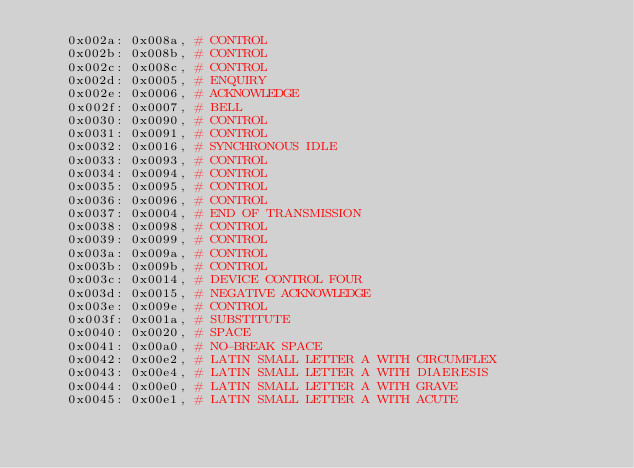Convert code to text. <code><loc_0><loc_0><loc_500><loc_500><_Python_>	0x002a: 0x008a,	# CONTROL
	0x002b: 0x008b,	# CONTROL
	0x002c: 0x008c,	# CONTROL
	0x002d: 0x0005,	# ENQUIRY
	0x002e: 0x0006,	# ACKNOWLEDGE
	0x002f: 0x0007,	# BELL
	0x0030: 0x0090,	# CONTROL
	0x0031: 0x0091,	# CONTROL
	0x0032: 0x0016,	# SYNCHRONOUS IDLE
	0x0033: 0x0093,	# CONTROL
	0x0034: 0x0094,	# CONTROL
	0x0035: 0x0095,	# CONTROL
	0x0036: 0x0096,	# CONTROL
	0x0037: 0x0004,	# END OF TRANSMISSION
	0x0038: 0x0098,	# CONTROL
	0x0039: 0x0099,	# CONTROL
	0x003a: 0x009a,	# CONTROL
	0x003b: 0x009b,	# CONTROL
	0x003c: 0x0014,	# DEVICE CONTROL FOUR
	0x003d: 0x0015,	# NEGATIVE ACKNOWLEDGE
	0x003e: 0x009e,	# CONTROL
	0x003f: 0x001a,	# SUBSTITUTE
	0x0040: 0x0020,	# SPACE
	0x0041: 0x00a0,	# NO-BREAK SPACE
	0x0042: 0x00e2,	# LATIN SMALL LETTER A WITH CIRCUMFLEX
	0x0043: 0x00e4,	# LATIN SMALL LETTER A WITH DIAERESIS
	0x0044: 0x00e0,	# LATIN SMALL LETTER A WITH GRAVE
	0x0045: 0x00e1,	# LATIN SMALL LETTER A WITH ACUTE</code> 